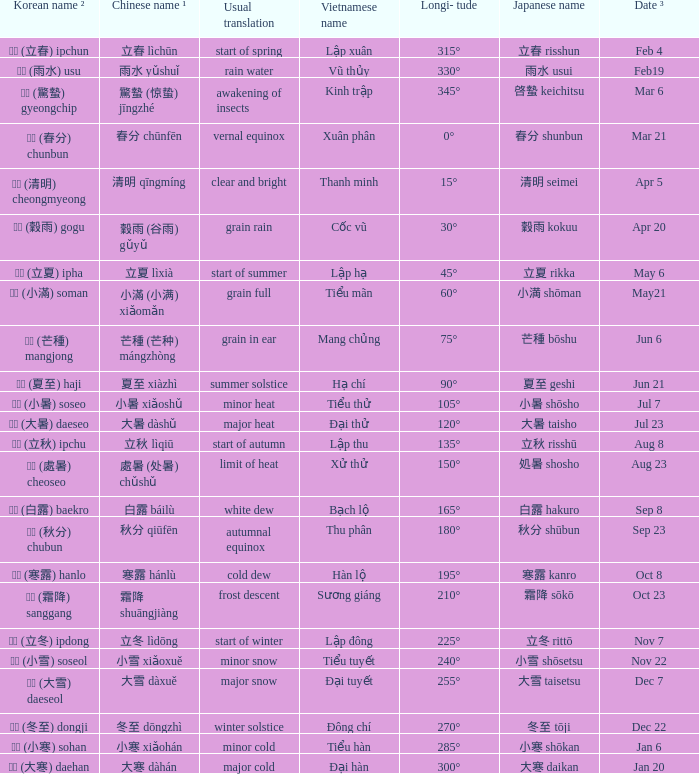WHich Usual translation is on sep 23? Autumnal equinox. 